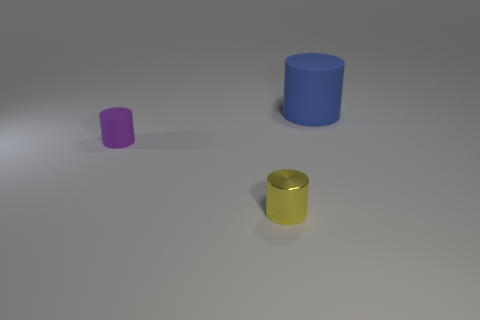Add 2 green shiny spheres. How many objects exist? 5 Subtract 0 gray cylinders. How many objects are left? 3 Subtract all big cylinders. Subtract all tiny purple things. How many objects are left? 1 Add 3 large rubber cylinders. How many large rubber cylinders are left? 4 Add 1 tiny cylinders. How many tiny cylinders exist? 3 